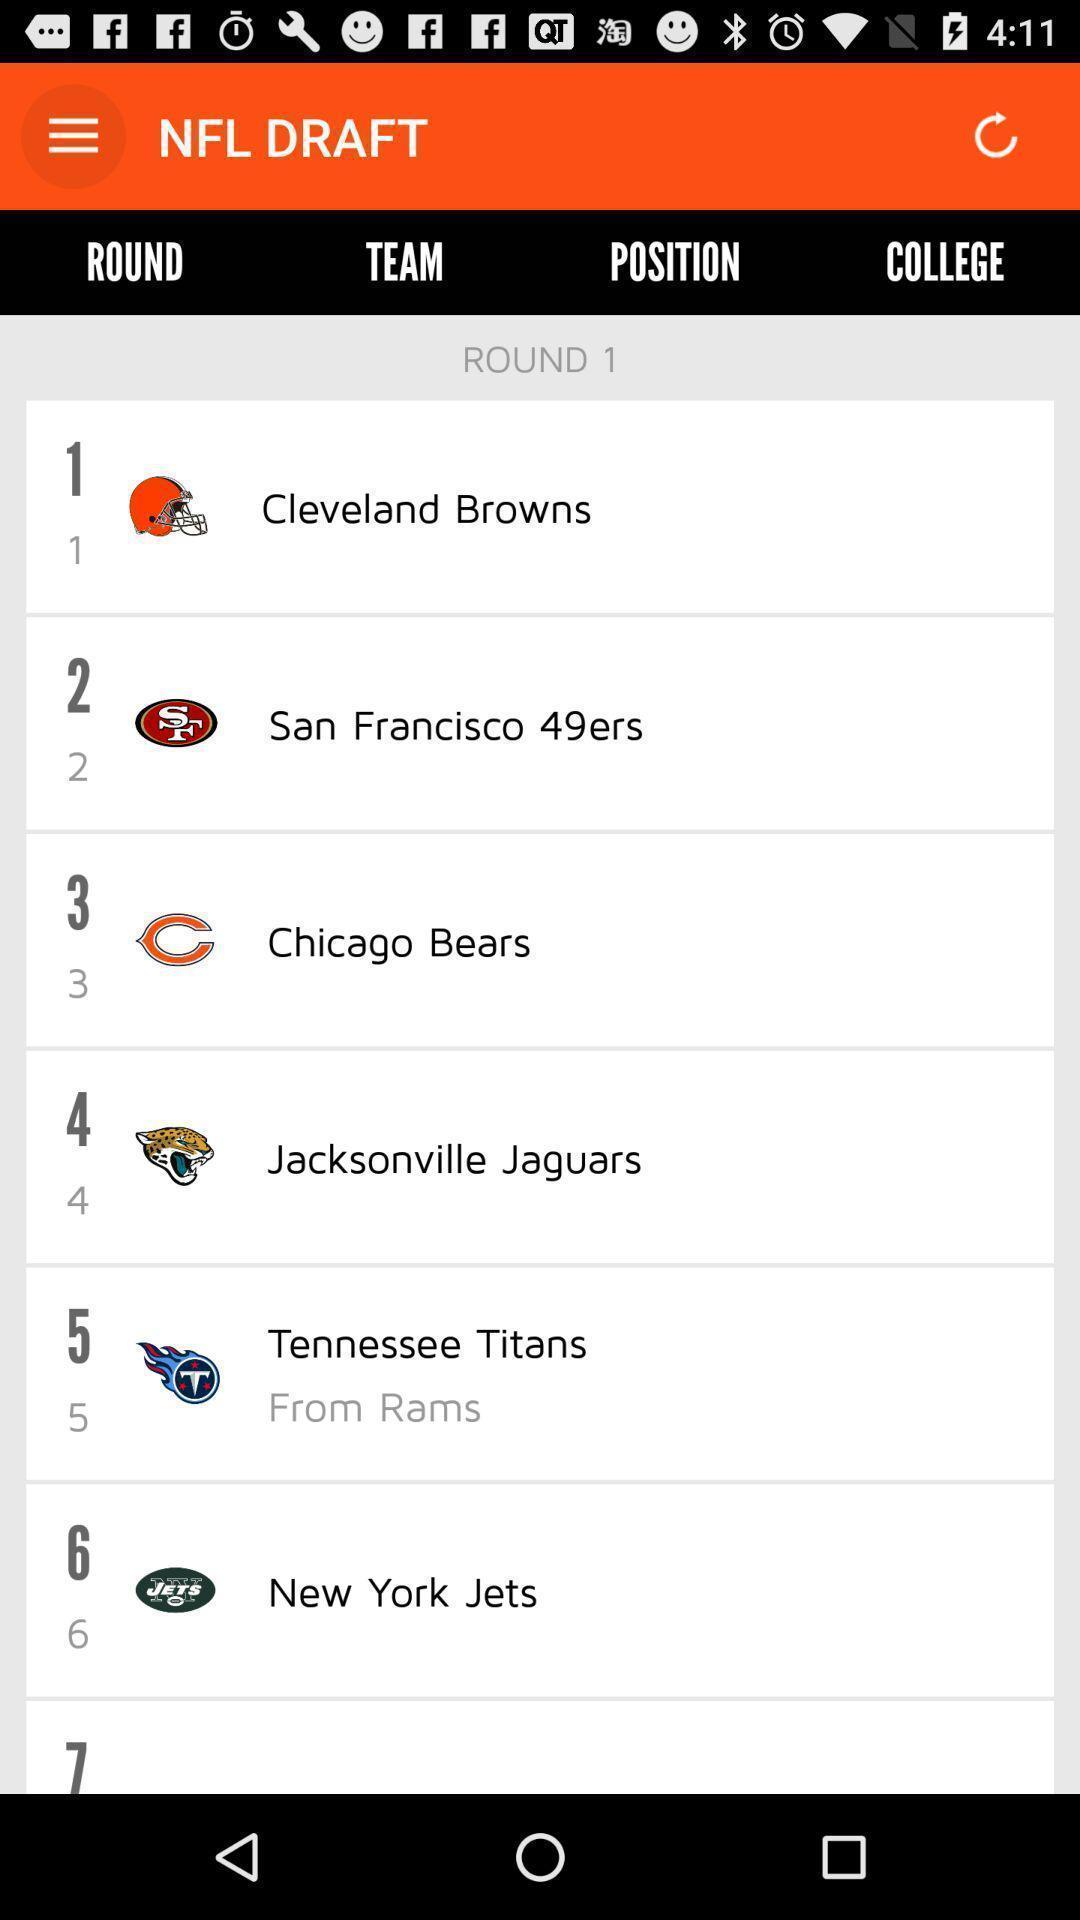Tell me what you see in this picture. Page displaying list of teams in a sports app. 